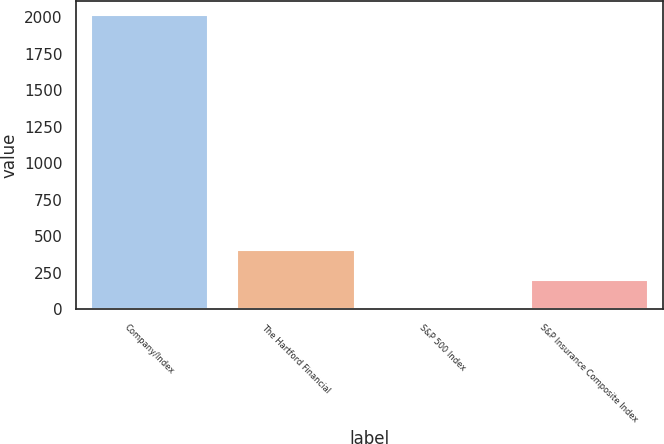Convert chart to OTSL. <chart><loc_0><loc_0><loc_500><loc_500><bar_chart><fcel>Company/Index<fcel>The Hartford Financial<fcel>S&P 500 Index<fcel>S&P Insurance Composite Index<nl><fcel>2015<fcel>404.1<fcel>1.38<fcel>202.74<nl></chart> 